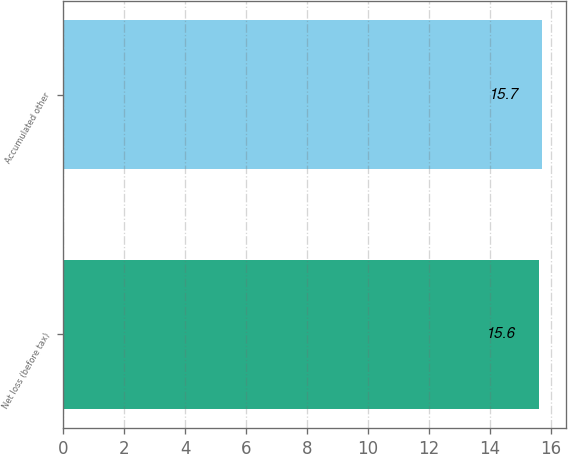Convert chart. <chart><loc_0><loc_0><loc_500><loc_500><bar_chart><fcel>Net loss (before tax)<fcel>Accumulated other<nl><fcel>15.6<fcel>15.7<nl></chart> 